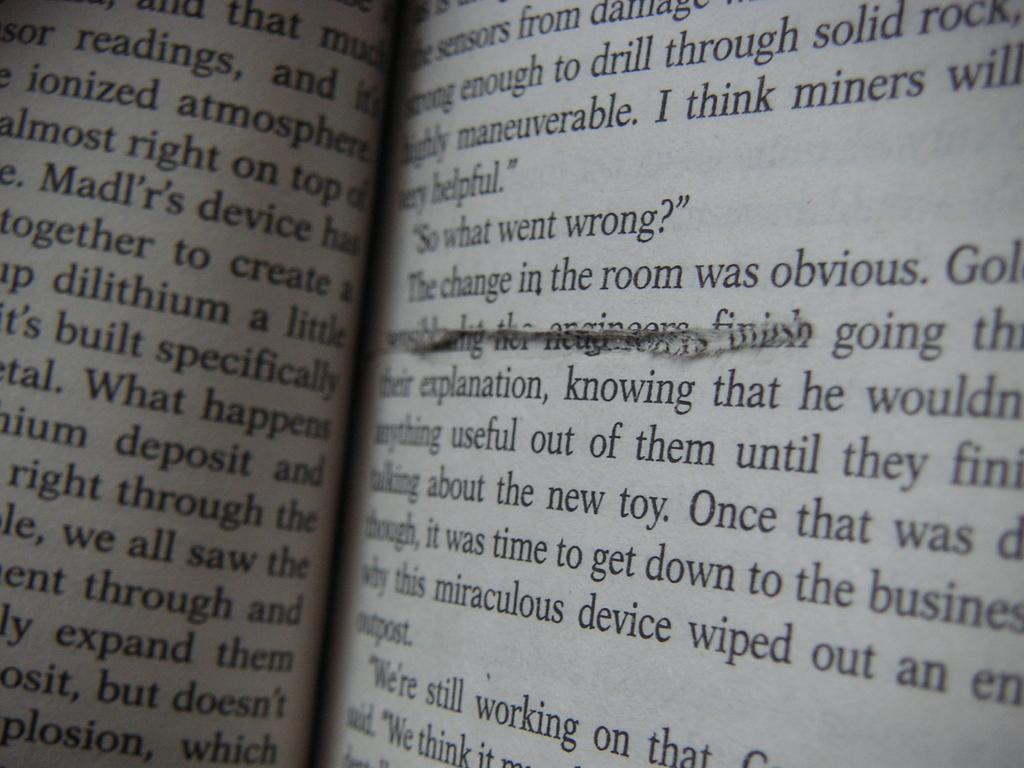<image>
Give a short and clear explanation of the subsequent image. An open book shows part of two pages which discuss stuff such as dilithium, mining, and drilling through rock. 